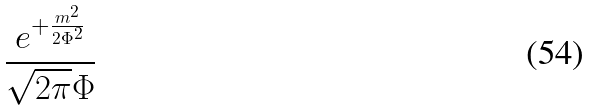Convert formula to latex. <formula><loc_0><loc_0><loc_500><loc_500>\frac { e ^ { + \frac { m ^ { 2 } } { 2 \Phi ^ { 2 } } } } { \sqrt { 2 \pi } \Phi }</formula> 